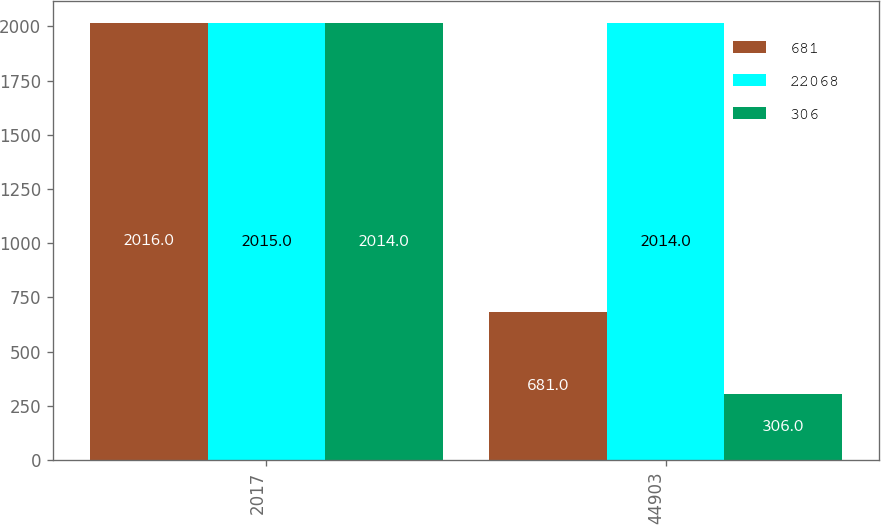Convert chart to OTSL. <chart><loc_0><loc_0><loc_500><loc_500><stacked_bar_chart><ecel><fcel>2017<fcel>44903<nl><fcel>681<fcel>2016<fcel>681<nl><fcel>22068<fcel>2015<fcel>2014<nl><fcel>306<fcel>2014<fcel>306<nl></chart> 